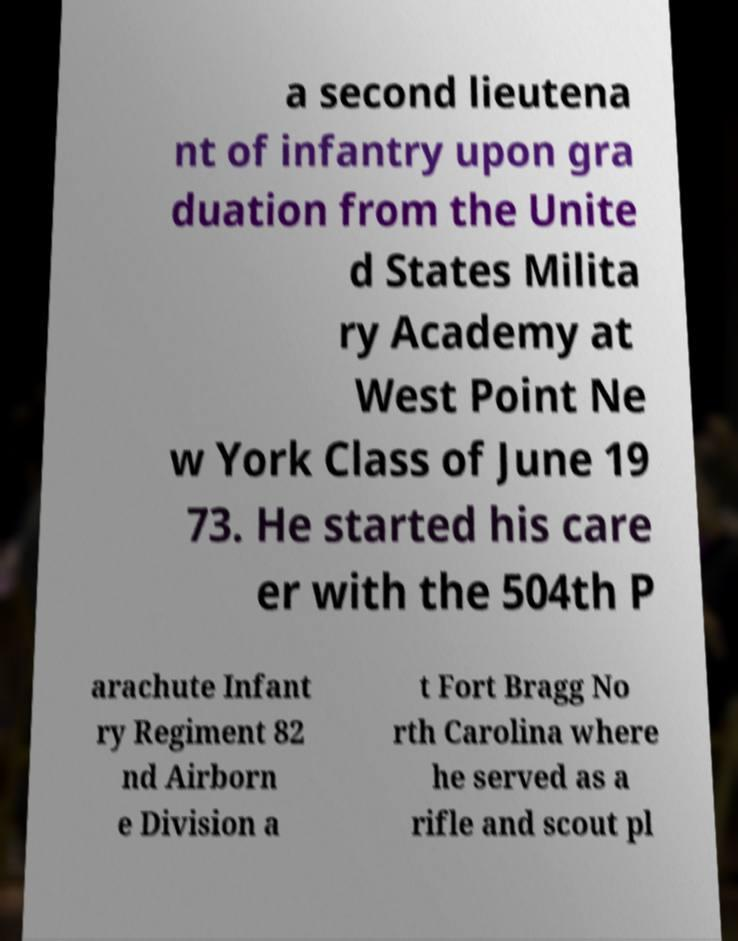Please read and relay the text visible in this image. What does it say? a second lieutena nt of infantry upon gra duation from the Unite d States Milita ry Academy at West Point Ne w York Class of June 19 73. He started his care er with the 504th P arachute Infant ry Regiment 82 nd Airborn e Division a t Fort Bragg No rth Carolina where he served as a rifle and scout pl 